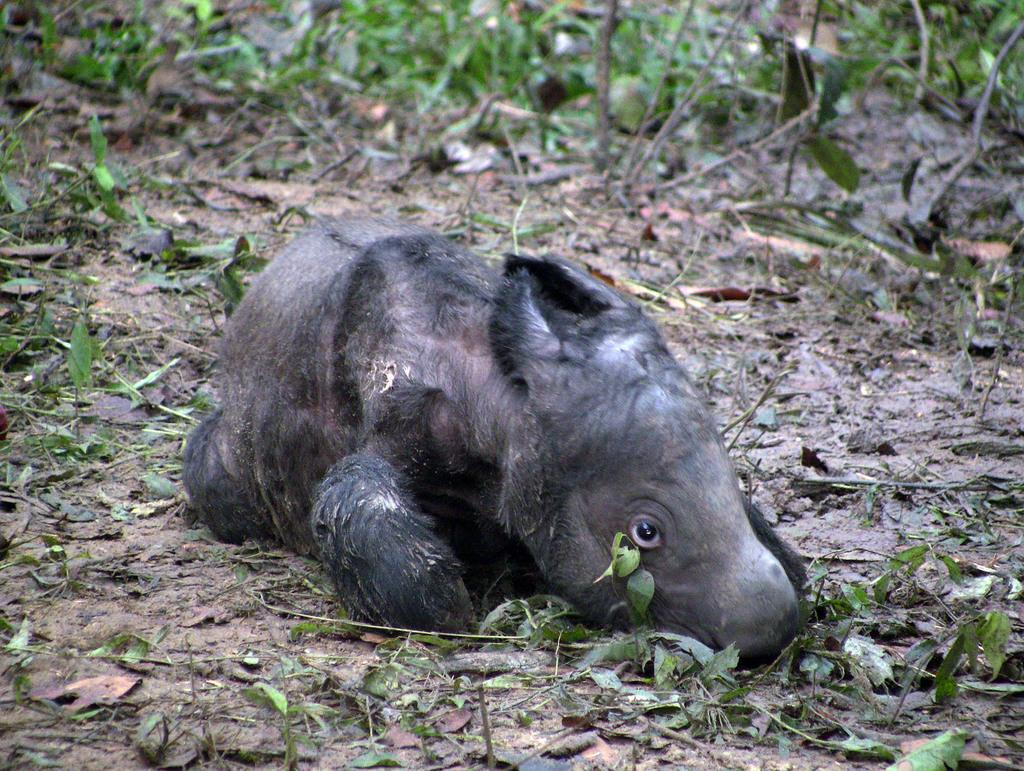What type of animal can be seen on the ground in the image? The animal present on the ground in the image is not specified, but it can be identified based on the provided facts. What color are the leaves in the image? The leaves in the image are green. What year is depicted in the image? The year is not depicted in the image, as it is a photograph or illustration of a scene and not a historical document. Can you see a toothbrush in the image? There is no toothbrush present in the image. 